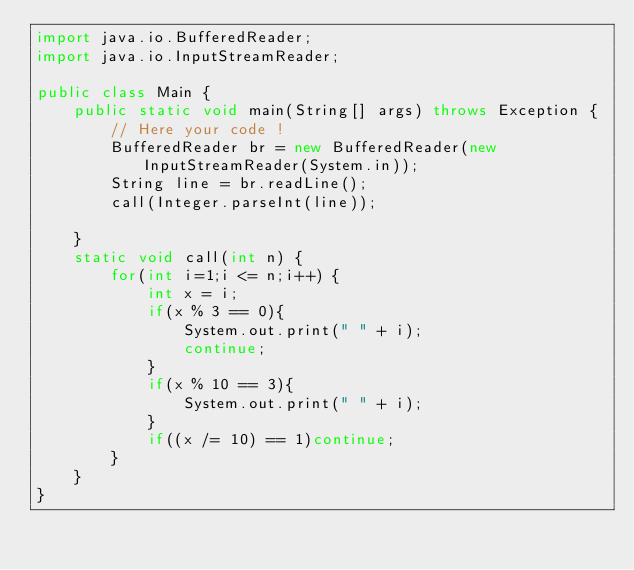Convert code to text. <code><loc_0><loc_0><loc_500><loc_500><_Java_>import java.io.BufferedReader;
import java.io.InputStreamReader;

public class Main {
    public static void main(String[] args) throws Exception {
        // Here your code !
        BufferedReader br = new BufferedReader(new InputStreamReader(System.in));
        String line = br.readLine();
        call(Integer.parseInt(line));

    }
    static void call(int n) {
        for(int i=1;i <= n;i++) {
            int x = i;
            if(x % 3 == 0){
                System.out.print(" " + i);
                continue;
            }
            if(x % 10 == 3){
                System.out.print(" " + i);
            }
            if((x /= 10) == 1)continue;
        }
    }
}</code> 